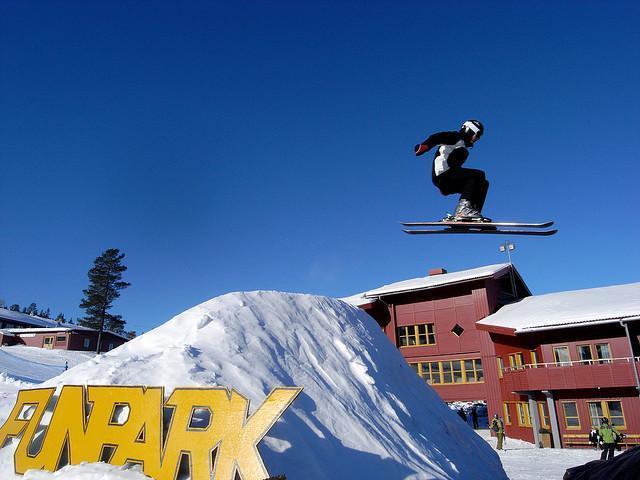How many cars in the picture?
Give a very brief answer. 0. 